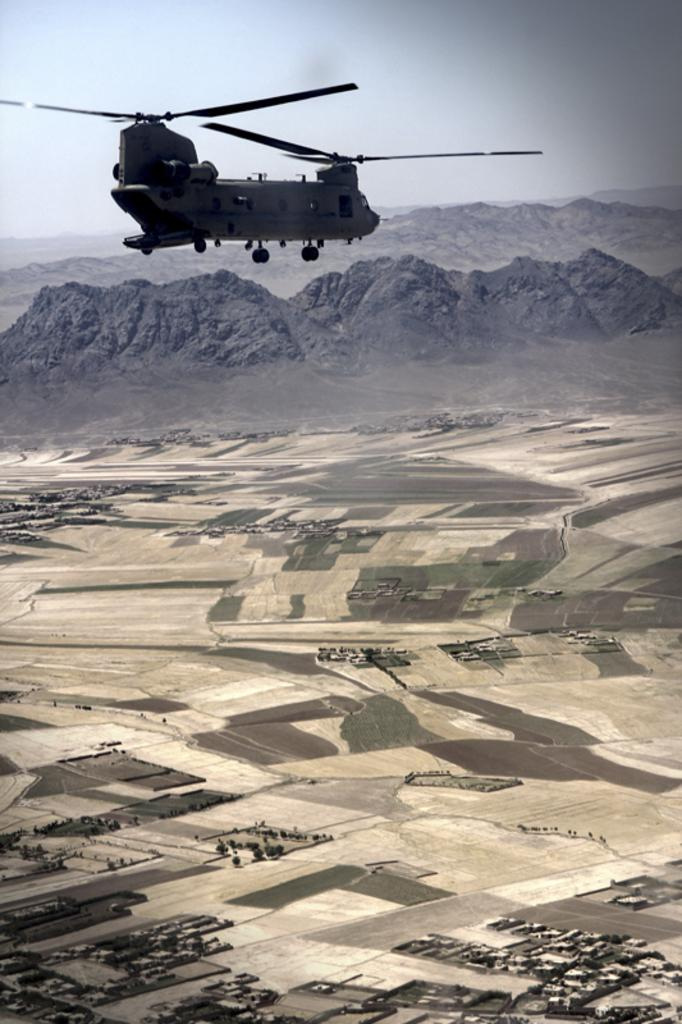What is flying in the air in the image? There is a helicopter flying in the air in the image. What can be seen below the helicopter? The ground is visible in the image. What type of natural feature is present in the image? There is a mountain in the image. What is visible in the background of the image? The sky is visible in the background of the image. Can you hear the sound of a seed being combed in the image? There is no sound or combing of seeds present in the image; it is a visual representation of a helicopter flying near a mountain. 